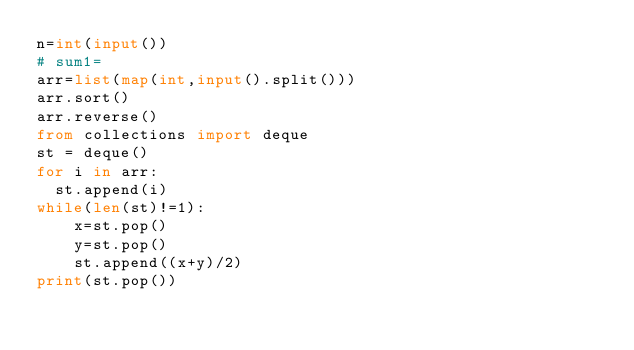<code> <loc_0><loc_0><loc_500><loc_500><_Python_>n=int(input())
# sum1=
arr=list(map(int,input().split()))
arr.sort()
arr.reverse()
from collections import deque 
st = deque()
for i in arr:
  st.append(i)
while(len(st)!=1):
    x=st.pop()
    y=st.pop()
    st.append((x+y)/2)
print(st.pop())
</code> 